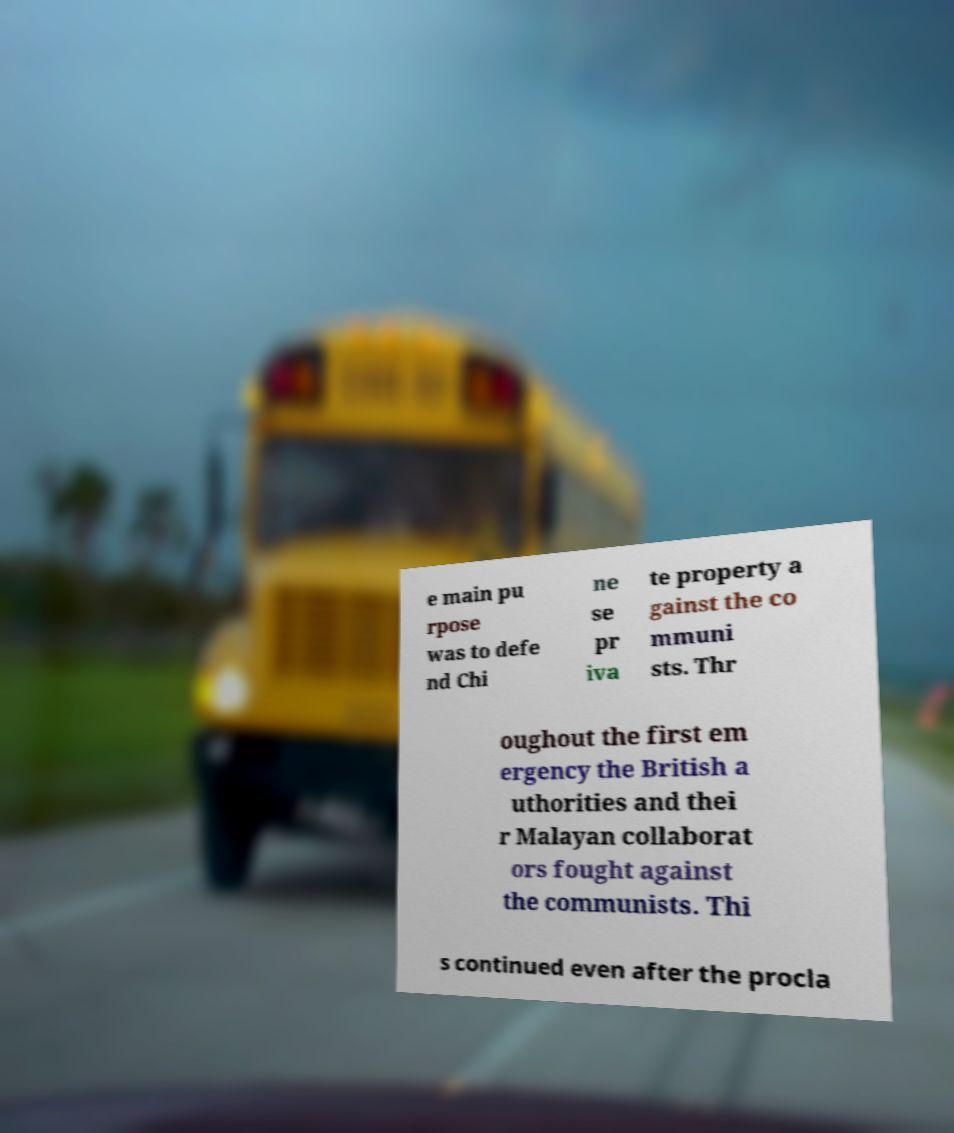I need the written content from this picture converted into text. Can you do that? e main pu rpose was to defe nd Chi ne se pr iva te property a gainst the co mmuni sts. Thr oughout the first em ergency the British a uthorities and thei r Malayan collaborat ors fought against the communists. Thi s continued even after the procla 